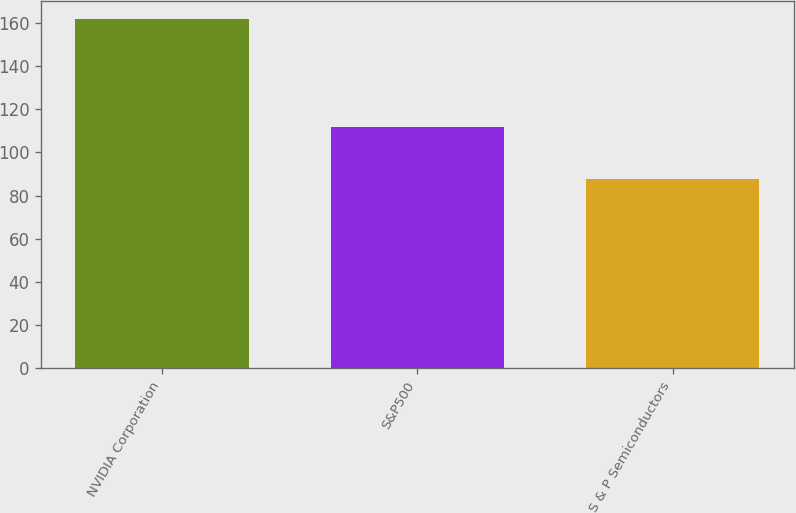<chart> <loc_0><loc_0><loc_500><loc_500><bar_chart><fcel>NVIDIA Corporation<fcel>S&P500<fcel>S & P Semiconductors<nl><fcel>161.84<fcel>111.87<fcel>87.75<nl></chart> 